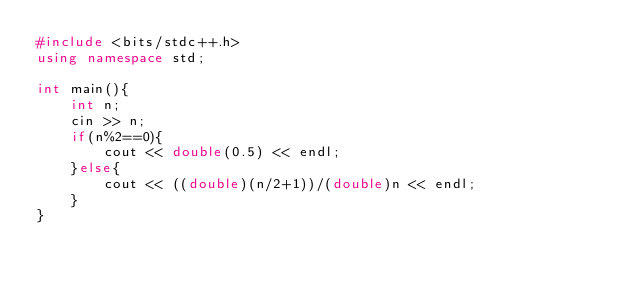Convert code to text. <code><loc_0><loc_0><loc_500><loc_500><_C++_>#include <bits/stdc++.h>
using namespace std;

int main(){
    int n;
    cin >> n;
    if(n%2==0){
        cout << double(0.5) << endl;
    }else{
        cout << ((double)(n/2+1))/(double)n << endl;
    }
}</code> 